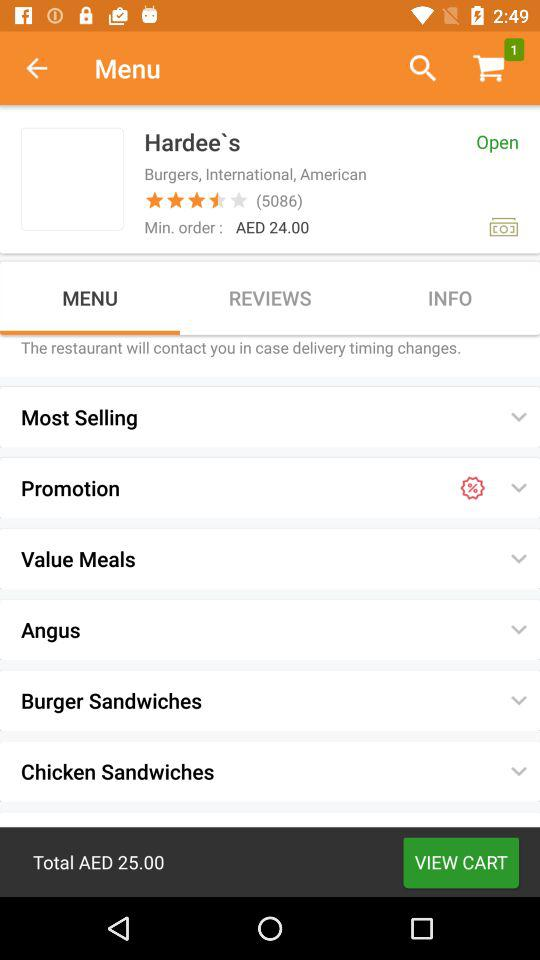What is the number of customers who share their opinions? The number of customers is 5086. 